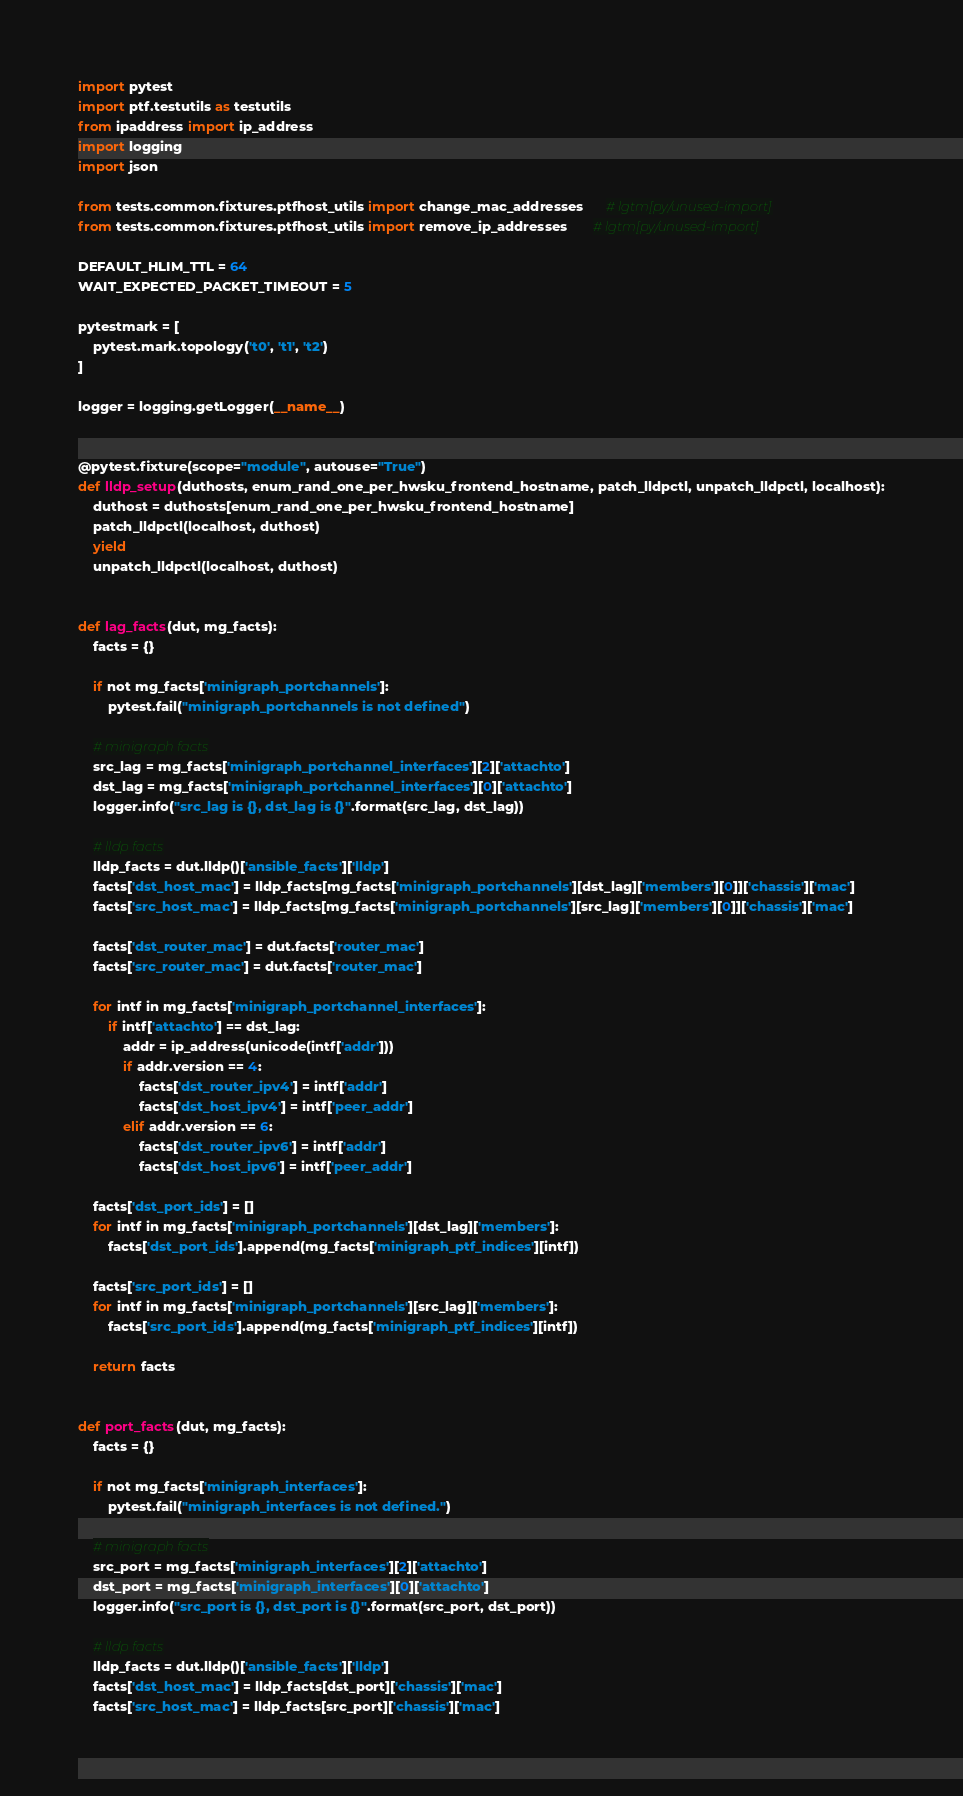Convert code to text. <code><loc_0><loc_0><loc_500><loc_500><_Python_>import pytest
import ptf.testutils as testutils
from ipaddress import ip_address
import logging
import json

from tests.common.fixtures.ptfhost_utils import change_mac_addresses      # lgtm[py/unused-import]
from tests.common.fixtures.ptfhost_utils import remove_ip_addresses       # lgtm[py/unused-import]

DEFAULT_HLIM_TTL = 64
WAIT_EXPECTED_PACKET_TIMEOUT = 5

pytestmark = [
    pytest.mark.topology('t0', 't1', 't2')
]

logger = logging.getLogger(__name__)


@pytest.fixture(scope="module", autouse="True")
def lldp_setup(duthosts, enum_rand_one_per_hwsku_frontend_hostname, patch_lldpctl, unpatch_lldpctl, localhost):
    duthost = duthosts[enum_rand_one_per_hwsku_frontend_hostname]
    patch_lldpctl(localhost, duthost)
    yield
    unpatch_lldpctl(localhost, duthost)


def lag_facts(dut, mg_facts):
    facts = {}

    if not mg_facts['minigraph_portchannels']:
        pytest.fail("minigraph_portchannels is not defined")

    # minigraph facts
    src_lag = mg_facts['minigraph_portchannel_interfaces'][2]['attachto']
    dst_lag = mg_facts['minigraph_portchannel_interfaces'][0]['attachto']
    logger.info("src_lag is {}, dst_lag is {}".format(src_lag, dst_lag))

    # lldp facts
    lldp_facts = dut.lldp()['ansible_facts']['lldp']
    facts['dst_host_mac'] = lldp_facts[mg_facts['minigraph_portchannels'][dst_lag]['members'][0]]['chassis']['mac']
    facts['src_host_mac'] = lldp_facts[mg_facts['minigraph_portchannels'][src_lag]['members'][0]]['chassis']['mac']

    facts['dst_router_mac'] = dut.facts['router_mac']
    facts['src_router_mac'] = dut.facts['router_mac']

    for intf in mg_facts['minigraph_portchannel_interfaces']:
        if intf['attachto'] == dst_lag:
            addr = ip_address(unicode(intf['addr']))
            if addr.version == 4:
                facts['dst_router_ipv4'] = intf['addr']
                facts['dst_host_ipv4'] = intf['peer_addr']
            elif addr.version == 6:
                facts['dst_router_ipv6'] = intf['addr']
                facts['dst_host_ipv6'] = intf['peer_addr']

    facts['dst_port_ids'] = []
    for intf in mg_facts['minigraph_portchannels'][dst_lag]['members']:
        facts['dst_port_ids'].append(mg_facts['minigraph_ptf_indices'][intf])

    facts['src_port_ids'] = []
    for intf in mg_facts['minigraph_portchannels'][src_lag]['members']:
        facts['src_port_ids'].append(mg_facts['minigraph_ptf_indices'][intf])

    return facts


def port_facts(dut, mg_facts):
    facts = {}

    if not mg_facts['minigraph_interfaces']:
        pytest.fail("minigraph_interfaces is not defined.")

    # minigraph facts
    src_port = mg_facts['minigraph_interfaces'][2]['attachto']
    dst_port = mg_facts['minigraph_interfaces'][0]['attachto']
    logger.info("src_port is {}, dst_port is {}".format(src_port, dst_port))

    # lldp facts
    lldp_facts = dut.lldp()['ansible_facts']['lldp']
    facts['dst_host_mac'] = lldp_facts[dst_port]['chassis']['mac']
    facts['src_host_mac'] = lldp_facts[src_port]['chassis']['mac']
</code> 